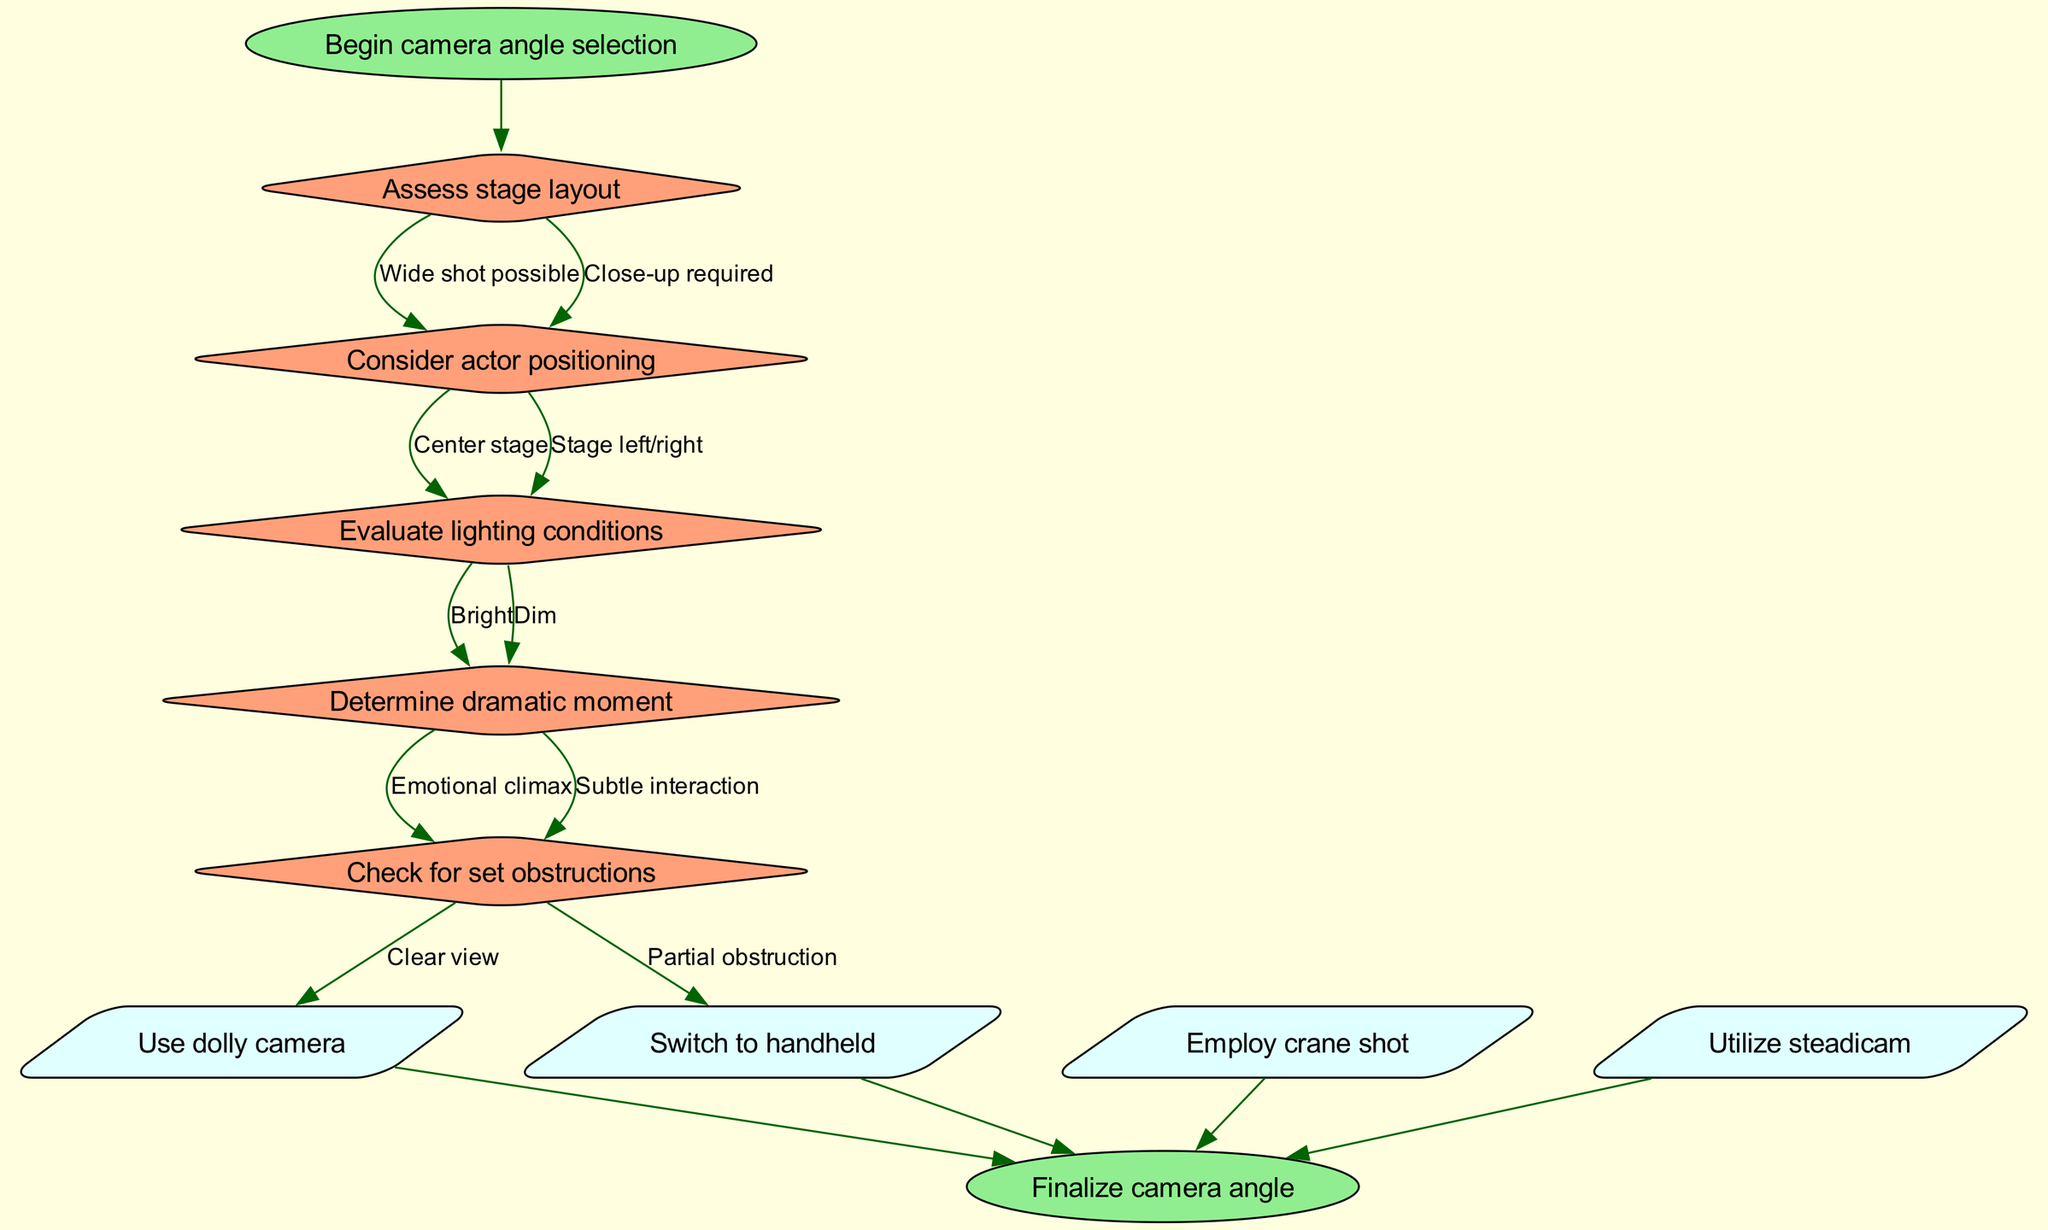What is the first step in the decision-making process? The diagram starts with the "Begin camera angle selection" node, indicating this is the initial step in the process.
Answer: Begin camera angle selection How many decision nodes are there in the diagram? There are five decision nodes in the diagram, each corresponding to a step in the decision-making process regarding camera angle selection.
Answer: 5 What are the edges leading from "Assess stage layout"? The "Assess stage layout" node has two edges leading to "Wide shot possible" and "Close-up required," indicating the possible outcomes of this decision.
Answer: Wide shot possible, Close-up required What camera technique is suggested for a "Dim" lighting condition? The diagram does not explicitly connect a lighting condition with a specific camera technique, so two potential decision paths might lead to different outcomes. Based on further context, you might consider a steadicam for versatility in low light, but the diagram alone does not provide this information.
Answer: Not clear What action can be taken after evaluating lighting conditions? After evaluating lighting conditions, the next action depends on the previous decisions made in the flowchart, leading to one of the action nodes that correspond to camera techniques.
Answer: Use dolly camera, Switch to handheld, Employ crane shot, Utilize steadicam What happens after checking for set obstructions? After checking for set obstructions, the flow generally leads to action nodes, suggesting that decisions regarding the angle will lead directly to selected actions for filming.
Answer: Finalize camera angle Which edge leads from "Determine dramatic moment"? The "Determine dramatic moment" node has two edges leading to "Emotional climax" and "Subtle interaction," representing different types of dramatic moments that may influence camera angle selection.
Answer: Emotional climax, Subtle interaction Which node leads to "Switch to handheld"? The flowchart indicates that after making various decisions, one of the potential actions is "Switch to handheld," but the exact preceding nodes depend on decision paths chosen.
Answer: Decision path from previous nodes What is the last action taken in the process? The final action in the flowchart is "Finalize camera angle," which occurs after all decisions and actions have been evaluated and executed.
Answer: Finalize camera angle 